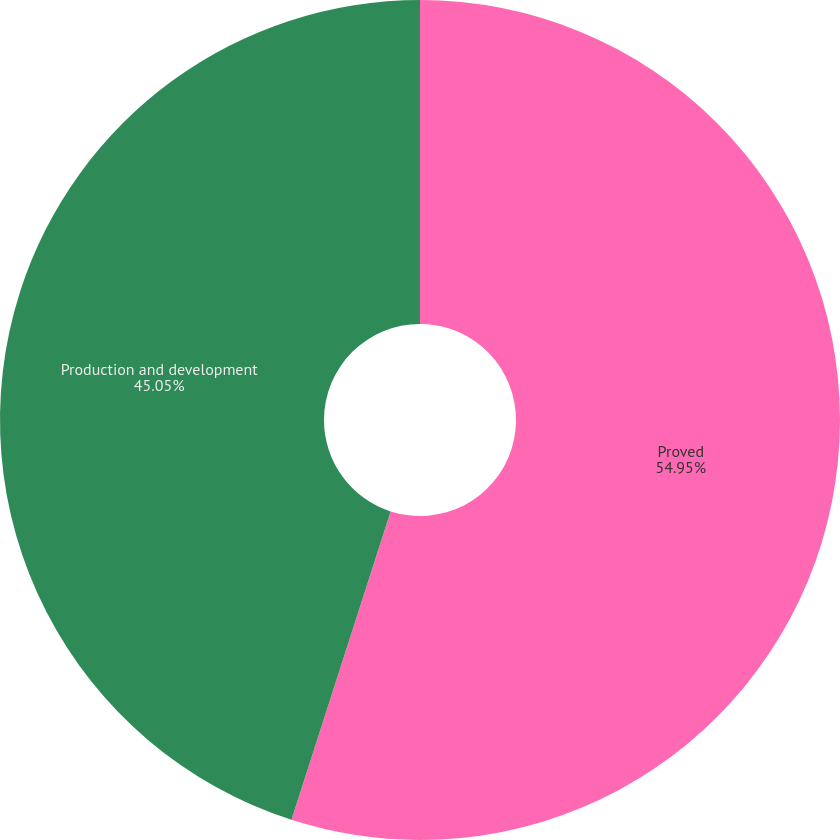<chart> <loc_0><loc_0><loc_500><loc_500><pie_chart><fcel>Proved<fcel>Production and development<nl><fcel>54.95%<fcel>45.05%<nl></chart> 